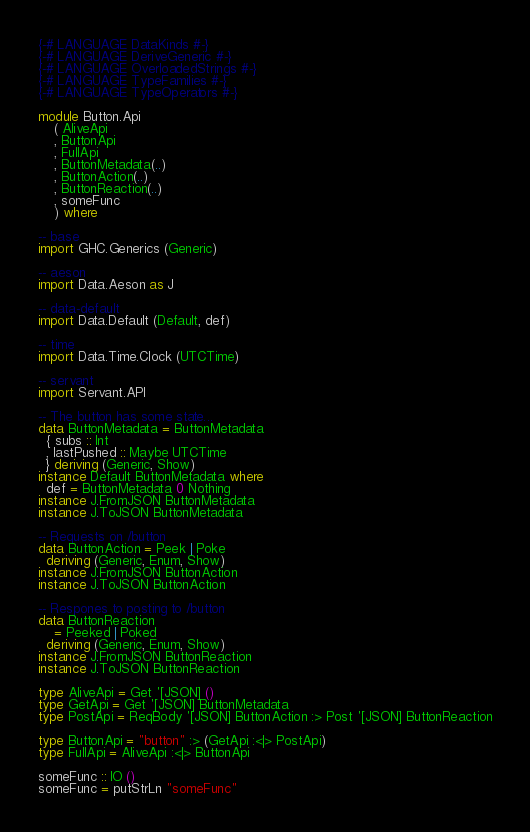<code> <loc_0><loc_0><loc_500><loc_500><_Haskell_>{-# LANGUAGE DataKinds #-}
{-# LANGUAGE DeriveGeneric #-}
{-# LANGUAGE OverloadedStrings #-}
{-# LANGUAGE TypeFamilies #-}
{-# LANGUAGE TypeOperators #-}

module Button.Api
    ( AliveApi
    , ButtonApi
    , FullApi
    , ButtonMetadata(..)
    , ButtonAction(..)
    , ButtonReaction(..)
    , someFunc
    ) where

-- base
import GHC.Generics (Generic)

-- aeson
import Data.Aeson as J

-- data-default
import Data.Default (Default, def)

-- time
import Data.Time.Clock (UTCTime)

-- servant
import Servant.API

-- The button has some state...
data ButtonMetadata = ButtonMetadata
  { subs :: Int
  , lastPushed :: Maybe UTCTime
  } deriving (Generic, Show)
instance Default ButtonMetadata where
  def = ButtonMetadata 0 Nothing
instance J.FromJSON ButtonMetadata
instance J.ToJSON ButtonMetadata

-- Requests on /button
data ButtonAction = Peek | Poke
  deriving (Generic, Enum, Show)
instance J.FromJSON ButtonAction
instance J.ToJSON ButtonAction

-- Respones to posting to /button
data ButtonReaction
    = Peeked | Poked
  deriving (Generic, Enum, Show)
instance J.FromJSON ButtonReaction
instance J.ToJSON ButtonReaction

type AliveApi = Get '[JSON] ()
type GetApi = Get '[JSON] ButtonMetadata
type PostApi = ReqBody '[JSON] ButtonAction :> Post '[JSON] ButtonReaction

type ButtonApi = "button" :> (GetApi :<|> PostApi)
type FullApi = AliveApi :<|> ButtonApi

someFunc :: IO ()
someFunc = putStrLn "someFunc"
</code> 